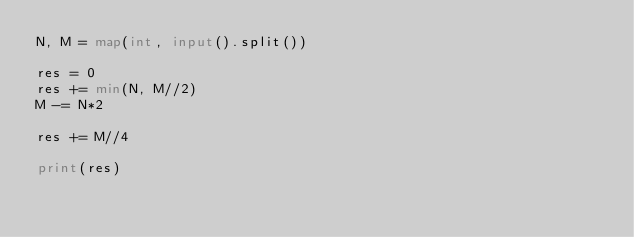Convert code to text. <code><loc_0><loc_0><loc_500><loc_500><_Python_>N, M = map(int, input().split())

res = 0
res += min(N, M//2)
M -= N*2

res += M//4

print(res)</code> 